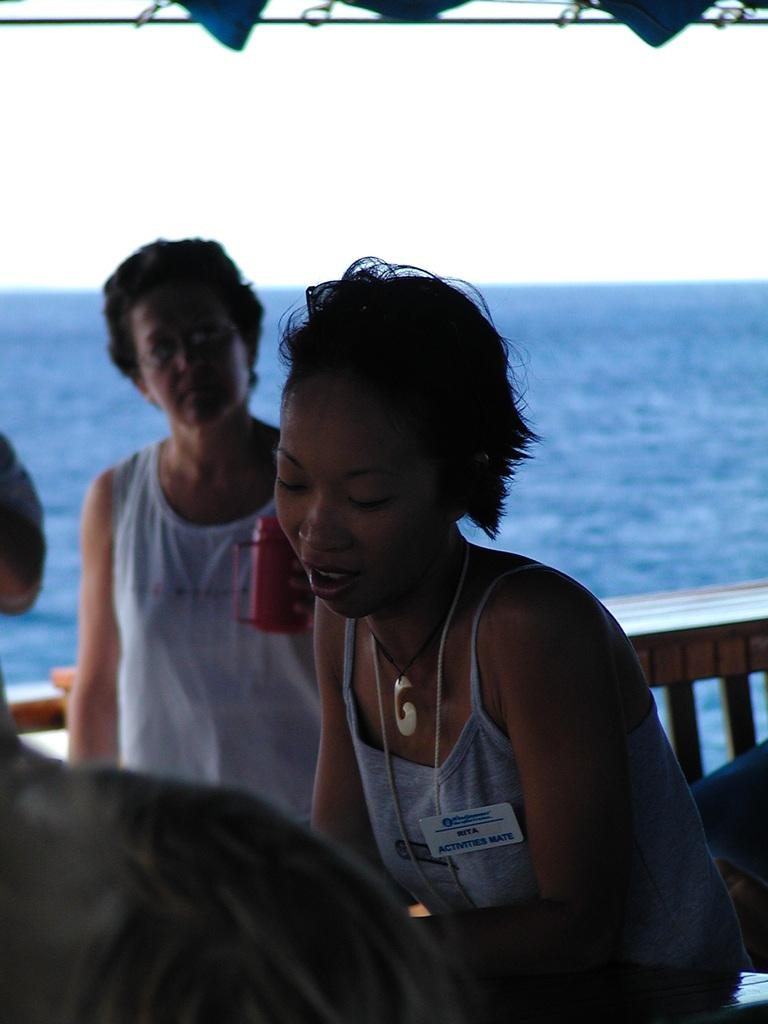How many women are in the image? There are two women in the image. What are the women holding in the image? One woman is holding an identity card, and the other woman is holding a red mug. What can be seen in the background of the image? There is a beach in the background of the image. What is the taste of the identity card in the image? The identity card is not something that can be tasted, as it is a piece of paper or plastic with information printed on it. 